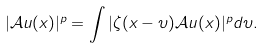Convert formula to latex. <formula><loc_0><loc_0><loc_500><loc_500>| \mathcal { A } u ( x ) | ^ { p } = \int | \zeta ( x - \upsilon ) \mathcal { A } u ( x ) | ^ { p } d \upsilon .</formula> 